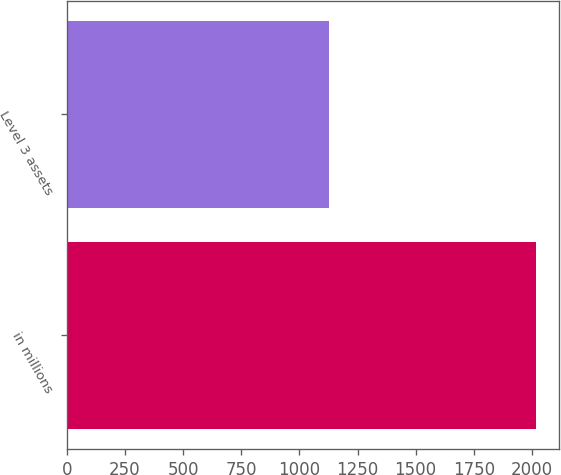Convert chart. <chart><loc_0><loc_0><loc_500><loc_500><bar_chart><fcel>in millions<fcel>Level 3 assets<nl><fcel>2017<fcel>1126<nl></chart> 